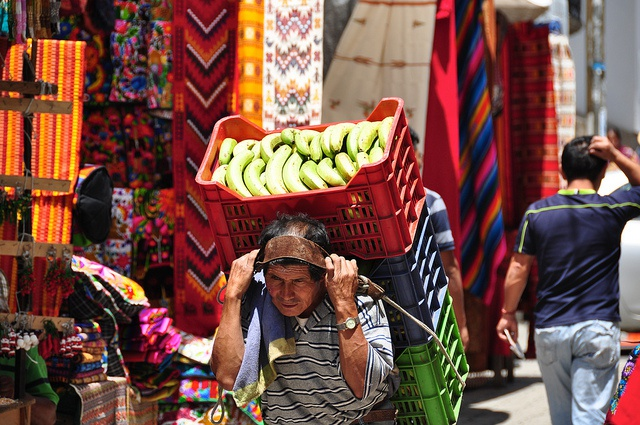Describe the objects in this image and their specific colors. I can see people in black, gray, and maroon tones, people in black, gray, navy, and lightgray tones, people in black, maroon, gray, and lavender tones, banana in black, lightyellow, khaki, and olive tones, and banana in black, lightyellow, and khaki tones in this image. 